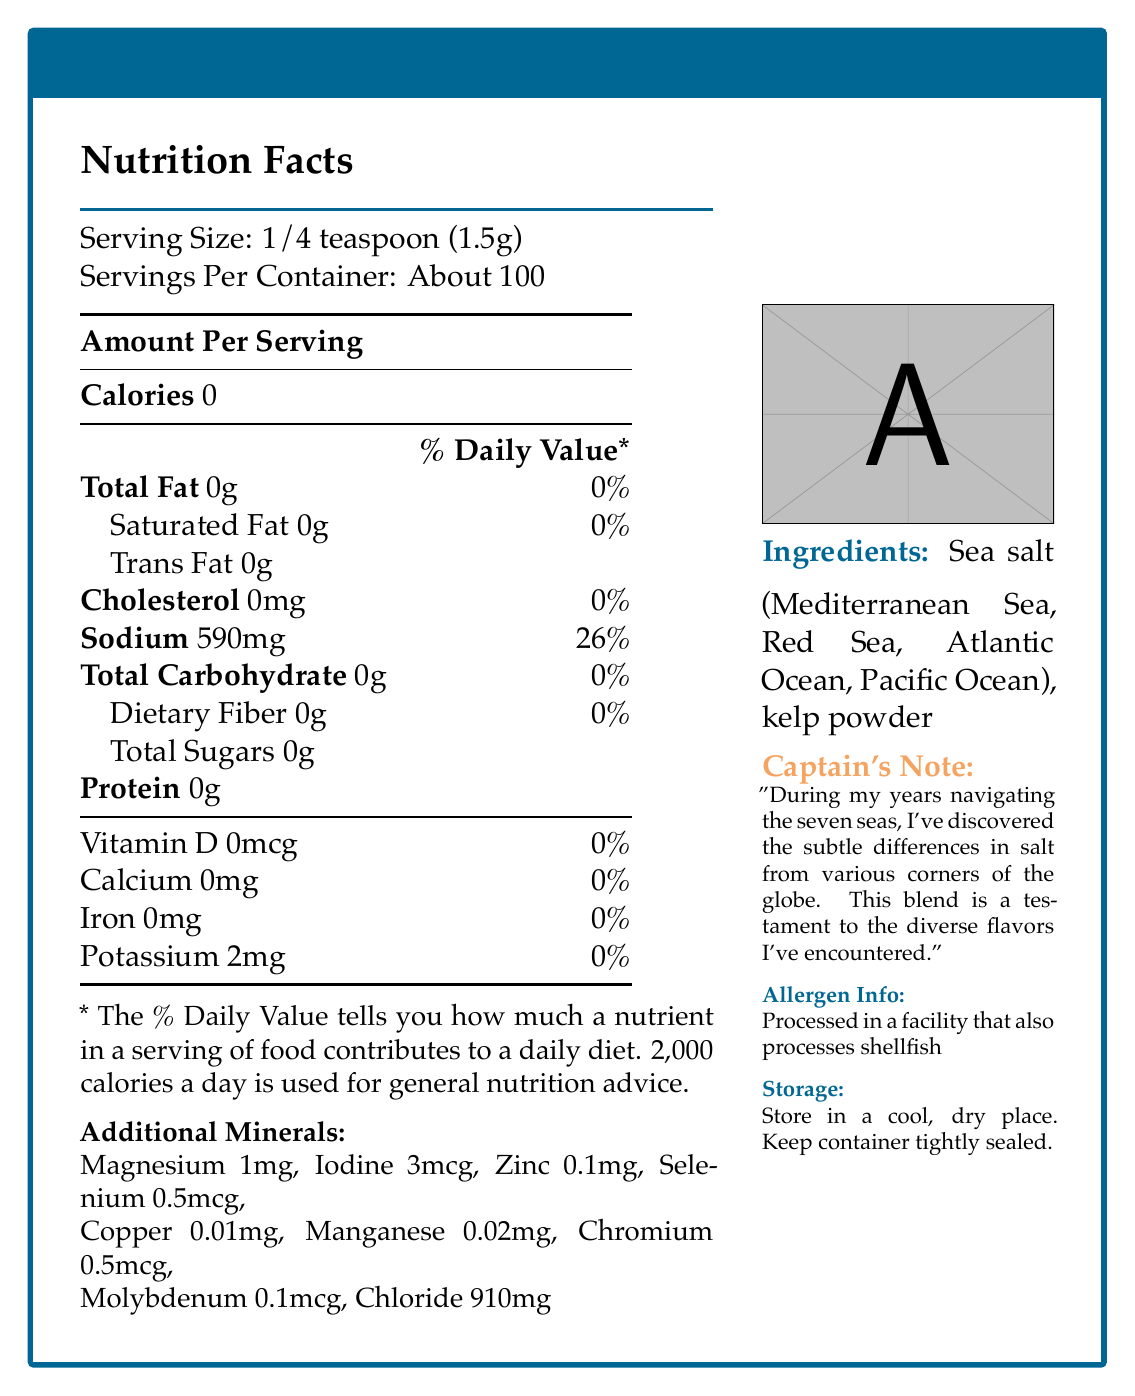what is the serving size? The serving size is explicitly mentioned in the Nutrition Facts section of the document.
Answer: 1/4 teaspoon (1.5g) how many servings are in a container? This information is located right under the serving size in the Nutrition Facts section.
Answer: About 100 how much sodium is in one serving? This is detailed in the Nutrition Facts table under the Amount Per Serving column.
Answer: 590mg list the additional minerals found in this sea salt blend The additional minerals are mentioned in the Nutrition Facts section under "Additional Minerals."
Answer: Magnesium, Iodine, Zinc, Selenium, Copper, Manganese, Chromium, Molybdenum, Chloride what are the ingredients? The ingredients are listed under the "Ingredients" section of the document.
Answer: Sea salt (Mediterranean Sea, Red Sea, Atlantic Ocean, Pacific Ocean), kelp powder how should this sea salt blend be stored? Storage instructions are provided near the bottom of the document.
Answer: Store in a cool, dry place. Keep container tightly sealed. where does the sea salt in the blend come from? The origin of the sea salt is listed in the ingredients section.
Answer: Mediterranean Sea, Red Sea, Atlantic Ocean, Pacific Ocean how much chloride is in one serving? The amount of chloride per serving is listed under "Additional Minerals."
Answer: 910mg what is the allergen information for this sea salt blend? The allergen info is included in the document and specifies that it is processed in a facility with shellfish.
Answer: Processed in a facility that also processes shellfish describe the main idea of the document. The whole document is centered around informing the consumer about everything they need to know about Captain's Choice Sea Salt Blend, from its nutritional content to its origin and usability.
Answer: The document provides detailed nutritional information, ingredients, storage instructions, and other relevant data for Captain's Choice Sea Salt Blend, which is a special sea salt containing trace minerals from various oceans. what are the calorie contents per serving? A. 0 calories B. 50 calories C. 100 calories D. 200 calories The document specifies that the sea salt blend has 0 calories per serving.
Answer: A. 0 calories which of these minerals is NOT listed in the sea salt blend? A. Iron B. Magnesium C. Zinc D. Selenium Iron is not listed under the "Additional Minerals" section, whereas the other options are included.
Answer: A. Iron does this product contain any dietary fiber? The Nutrition Facts section shows that there is 0g of dietary fiber per serving.
Answer: No is harvesting this sea salt blend harmful to marine ecosystems? The sustainability statement clarifies that the sea salt is harvested using traditional methods that respect marine ecosystems and protect local wildlife.
Answer: No can the amount of potassium in one serving improve overall potassium levels significantly? The amount of potassium in one serving is only 2mg, which is very minimal and unlikely to significantly improve overall potassium levels.
Answer: No why does the captain note that this blend is a testament to diverse flavors? The Captain's Note elaborates that the blend includes sea salts from different oceanic regions, contributing to the diverse flavors experienced in the blend.
Answer: The captain's note mentions that the blend combines flavors from various corners of the globe, a reflection of the diverse regions from which the sea salt is sourced. are any carbohydrates present in the Captain's Choice Sea Salt Blend? The document shows that the total carbohydrate content per serving is 0g, indicating there are no carbohydrates present.
Answer: No what is the protein content per serving? The amount of protein per serving is clearly listed as 0g in the Nutrition Facts section.
Answer: 0g what is the recommended usage for this sea salt blend? The usage suggestions provided in the document list these specific recommendations.
Answer: Sprinkle on grilled fish, use as a finishing salt for seafood dishes, or rim your glass for the perfect margarita. how many micrograms of iodine are in each serving? The iodine content per serving is listed under "Additional Minerals."
Answer: 3mcg what percentage of the daily value of sodium does one serving contain? The Nutritional Facts table indicates that one serving contains 26% of the daily value for sodium.
Answer: 26% what is the flavor profile of this salt blend according to the product description? The description indicates that the blend brings together robust flavors from different oceanic regions, harvested during global expeditions.
Answer: The product description mentions robust flavors from various oceanic regions. what is the shelf life of the Captain's Choice Sea Salt Blend? The document does not provide any details regarding the shelf life of the sea salt blend.
Answer: Not enough information 